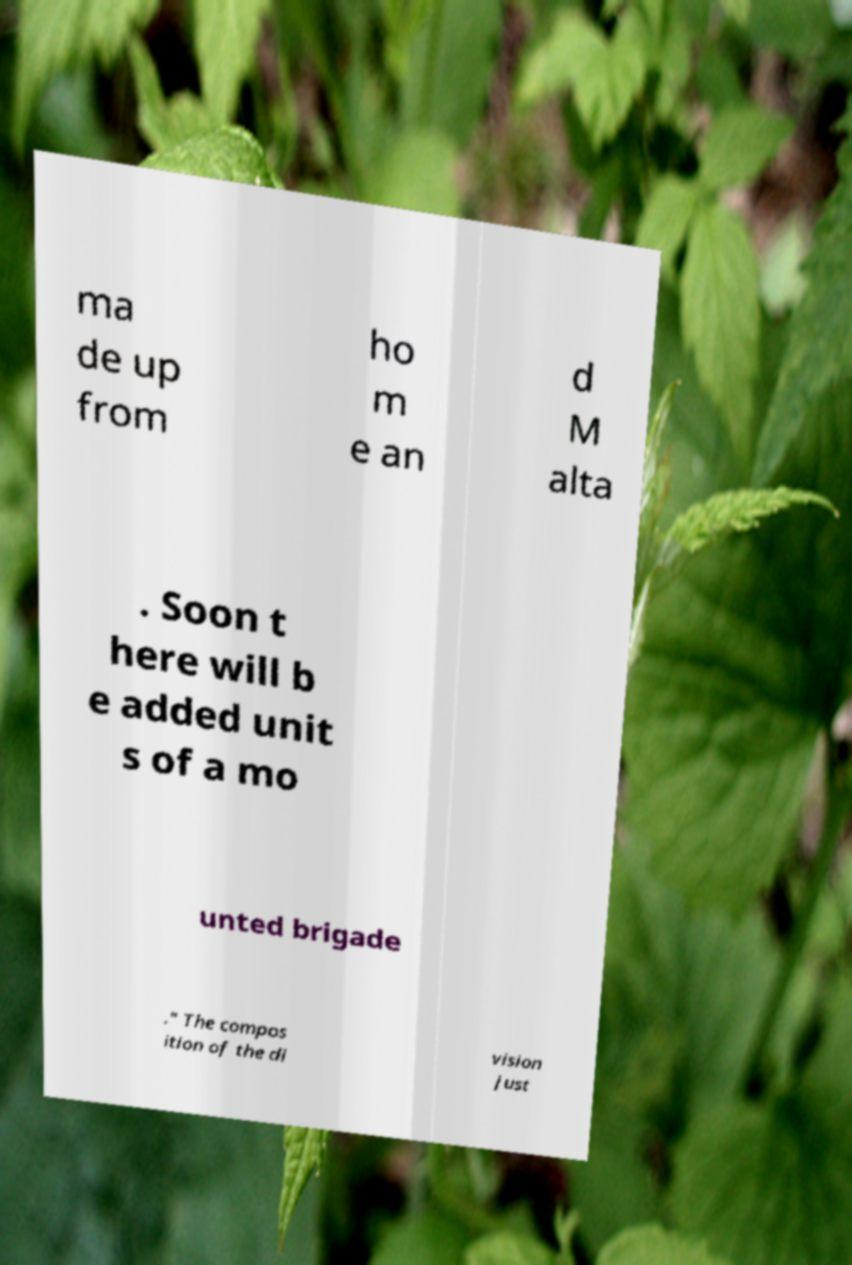Can you read and provide the text displayed in the image?This photo seems to have some interesting text. Can you extract and type it out for me? ma de up from ho m e an d M alta . Soon t here will b e added unit s of a mo unted brigade ." The compos ition of the di vision just 